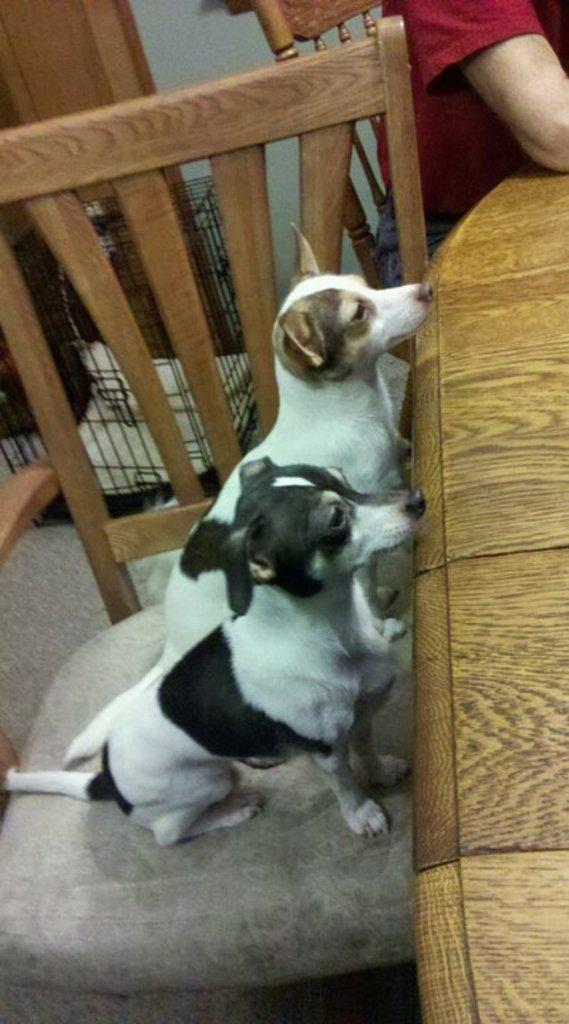What animals are on a chair in the center of the image? There are dogs on a chair in the center of the image. What are the dogs doing around the table? The dogs are around a table, which suggests they might be waiting for food or interacting with the person sitting nearby. Where is the person sitting in the image? There is a person sitting on a chair on the right top of the image. What can be seen in the background of the image? There is a wall visible in the background, as well as a cage. What type of credit can be seen being given to the dogs in the image? There is no credit being given to the dogs in the image; it is a still photograph and not a video or film. 